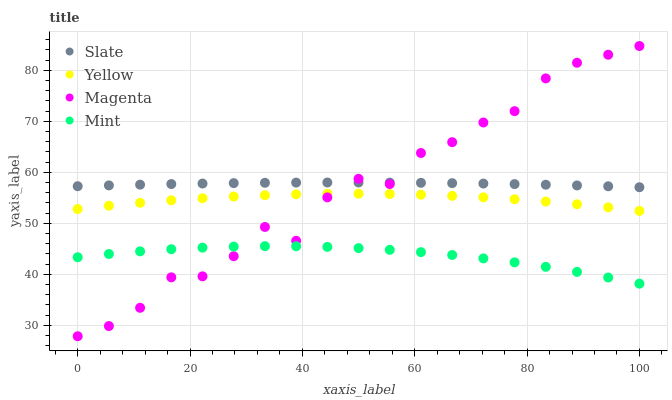Does Mint have the minimum area under the curve?
Answer yes or no. Yes. Does Slate have the maximum area under the curve?
Answer yes or no. Yes. Does Magenta have the minimum area under the curve?
Answer yes or no. No. Does Magenta have the maximum area under the curve?
Answer yes or no. No. Is Slate the smoothest?
Answer yes or no. Yes. Is Magenta the roughest?
Answer yes or no. Yes. Is Mint the smoothest?
Answer yes or no. No. Is Mint the roughest?
Answer yes or no. No. Does Magenta have the lowest value?
Answer yes or no. Yes. Does Mint have the lowest value?
Answer yes or no. No. Does Magenta have the highest value?
Answer yes or no. Yes. Does Mint have the highest value?
Answer yes or no. No. Is Mint less than Yellow?
Answer yes or no. Yes. Is Yellow greater than Mint?
Answer yes or no. Yes. Does Magenta intersect Mint?
Answer yes or no. Yes. Is Magenta less than Mint?
Answer yes or no. No. Is Magenta greater than Mint?
Answer yes or no. No. Does Mint intersect Yellow?
Answer yes or no. No. 